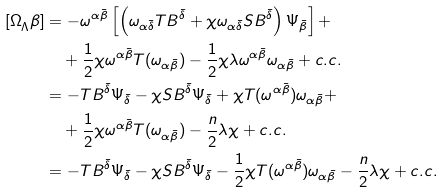Convert formula to latex. <formula><loc_0><loc_0><loc_500><loc_500>{ [ \Omega } _ { \Lambda } \beta ] & = - \omega ^ { \alpha \bar { \beta } } \left [ \left ( \omega _ { \alpha \bar { \delta } } T B ^ { \bar { \delta } } + \chi \omega _ { \alpha \bar { \delta } } S B ^ { \bar { \delta } } \right ) \Psi _ { \bar { \beta } } \right ] + \\ & \quad + \frac { 1 } { 2 } \chi \omega ^ { \alpha \bar { \beta } } T ( \omega _ { \alpha \bar { \beta } } ) - \frac { 1 } { 2 } \chi \lambda \omega ^ { \alpha \bar { \beta } } \omega _ { \alpha \bar { \beta } } + c . c . \\ & = - T B ^ { \bar { \delta } } \Psi _ { \bar { \delta } } - \chi S B ^ { \bar { \delta } } \Psi _ { \bar { \delta } } + \chi T ( \omega ^ { \alpha \bar { \beta } } ) \omega _ { \alpha \bar { \beta } } + \\ & \quad + \frac { 1 } { 2 } \chi \omega ^ { \alpha \bar { \beta } } T ( \omega _ { \alpha \bar { \beta } } ) - \frac { n } { 2 } \lambda \chi + c . c . \\ & = - T B ^ { \bar { \delta } } \Psi _ { \bar { \delta } } - \chi S B ^ { \bar { \delta } } \Psi _ { \bar { \delta } } - \frac { 1 } { 2 } \chi T ( \omega ^ { \alpha \bar { \beta } } ) \omega _ { \alpha \bar { \beta } } - \frac { n } { 2 } \lambda \chi + c . c .</formula> 